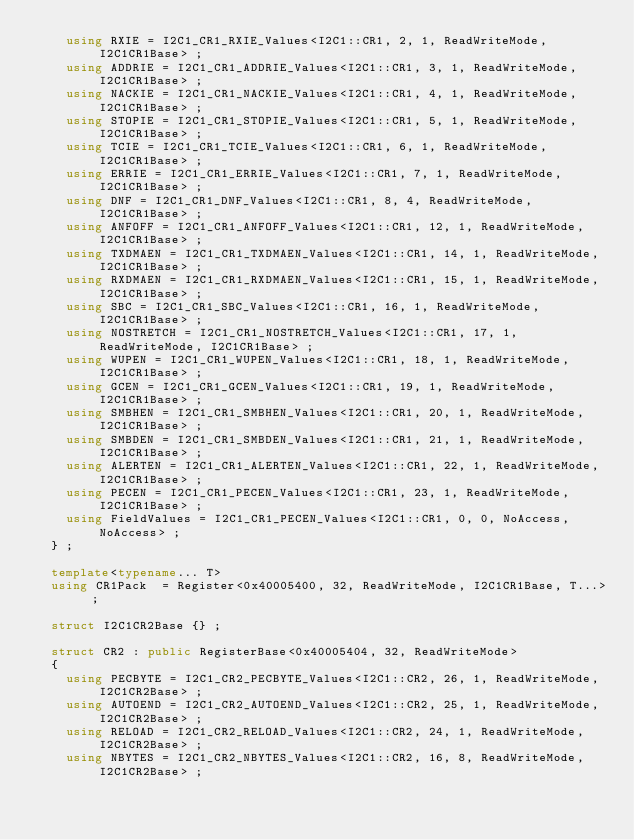<code> <loc_0><loc_0><loc_500><loc_500><_C++_>    using RXIE = I2C1_CR1_RXIE_Values<I2C1::CR1, 2, 1, ReadWriteMode, I2C1CR1Base> ;
    using ADDRIE = I2C1_CR1_ADDRIE_Values<I2C1::CR1, 3, 1, ReadWriteMode, I2C1CR1Base> ;
    using NACKIE = I2C1_CR1_NACKIE_Values<I2C1::CR1, 4, 1, ReadWriteMode, I2C1CR1Base> ;
    using STOPIE = I2C1_CR1_STOPIE_Values<I2C1::CR1, 5, 1, ReadWriteMode, I2C1CR1Base> ;
    using TCIE = I2C1_CR1_TCIE_Values<I2C1::CR1, 6, 1, ReadWriteMode, I2C1CR1Base> ;
    using ERRIE = I2C1_CR1_ERRIE_Values<I2C1::CR1, 7, 1, ReadWriteMode, I2C1CR1Base> ;
    using DNF = I2C1_CR1_DNF_Values<I2C1::CR1, 8, 4, ReadWriteMode, I2C1CR1Base> ;
    using ANFOFF = I2C1_CR1_ANFOFF_Values<I2C1::CR1, 12, 1, ReadWriteMode, I2C1CR1Base> ;
    using TXDMAEN = I2C1_CR1_TXDMAEN_Values<I2C1::CR1, 14, 1, ReadWriteMode, I2C1CR1Base> ;
    using RXDMAEN = I2C1_CR1_RXDMAEN_Values<I2C1::CR1, 15, 1, ReadWriteMode, I2C1CR1Base> ;
    using SBC = I2C1_CR1_SBC_Values<I2C1::CR1, 16, 1, ReadWriteMode, I2C1CR1Base> ;
    using NOSTRETCH = I2C1_CR1_NOSTRETCH_Values<I2C1::CR1, 17, 1, ReadWriteMode, I2C1CR1Base> ;
    using WUPEN = I2C1_CR1_WUPEN_Values<I2C1::CR1, 18, 1, ReadWriteMode, I2C1CR1Base> ;
    using GCEN = I2C1_CR1_GCEN_Values<I2C1::CR1, 19, 1, ReadWriteMode, I2C1CR1Base> ;
    using SMBHEN = I2C1_CR1_SMBHEN_Values<I2C1::CR1, 20, 1, ReadWriteMode, I2C1CR1Base> ;
    using SMBDEN = I2C1_CR1_SMBDEN_Values<I2C1::CR1, 21, 1, ReadWriteMode, I2C1CR1Base> ;
    using ALERTEN = I2C1_CR1_ALERTEN_Values<I2C1::CR1, 22, 1, ReadWriteMode, I2C1CR1Base> ;
    using PECEN = I2C1_CR1_PECEN_Values<I2C1::CR1, 23, 1, ReadWriteMode, I2C1CR1Base> ;
    using FieldValues = I2C1_CR1_PECEN_Values<I2C1::CR1, 0, 0, NoAccess, NoAccess> ;
  } ;

  template<typename... T> 
  using CR1Pack  = Register<0x40005400, 32, ReadWriteMode, I2C1CR1Base, T...> ;

  struct I2C1CR2Base {} ;

  struct CR2 : public RegisterBase<0x40005404, 32, ReadWriteMode>
  {
    using PECBYTE = I2C1_CR2_PECBYTE_Values<I2C1::CR2, 26, 1, ReadWriteMode, I2C1CR2Base> ;
    using AUTOEND = I2C1_CR2_AUTOEND_Values<I2C1::CR2, 25, 1, ReadWriteMode, I2C1CR2Base> ;
    using RELOAD = I2C1_CR2_RELOAD_Values<I2C1::CR2, 24, 1, ReadWriteMode, I2C1CR2Base> ;
    using NBYTES = I2C1_CR2_NBYTES_Values<I2C1::CR2, 16, 8, ReadWriteMode, I2C1CR2Base> ;</code> 